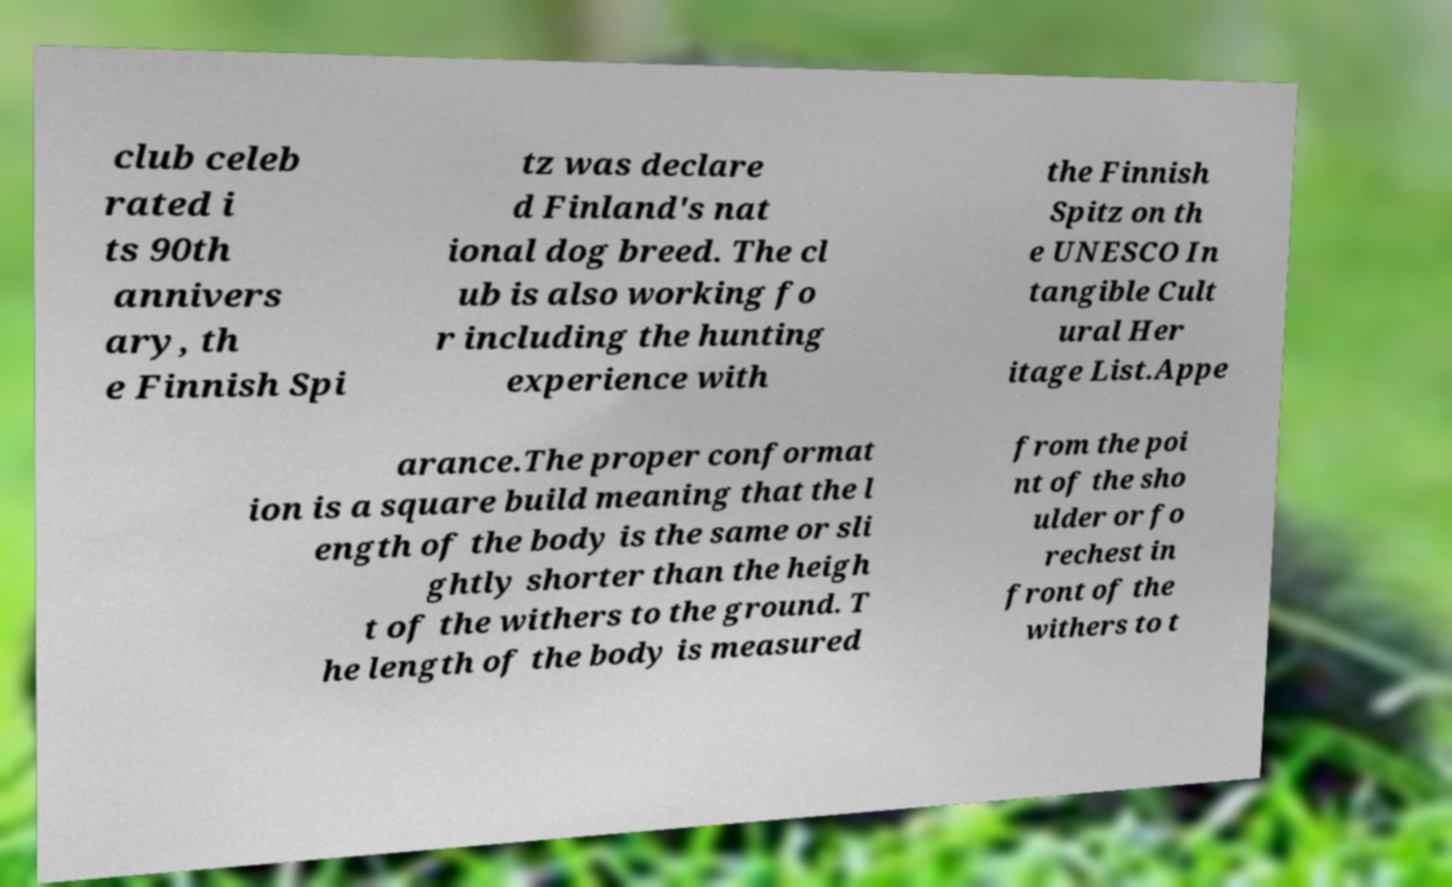Can you accurately transcribe the text from the provided image for me? club celeb rated i ts 90th annivers ary, th e Finnish Spi tz was declare d Finland's nat ional dog breed. The cl ub is also working fo r including the hunting experience with the Finnish Spitz on th e UNESCO In tangible Cult ural Her itage List.Appe arance.The proper conformat ion is a square build meaning that the l ength of the body is the same or sli ghtly shorter than the heigh t of the withers to the ground. T he length of the body is measured from the poi nt of the sho ulder or fo rechest in front of the withers to t 